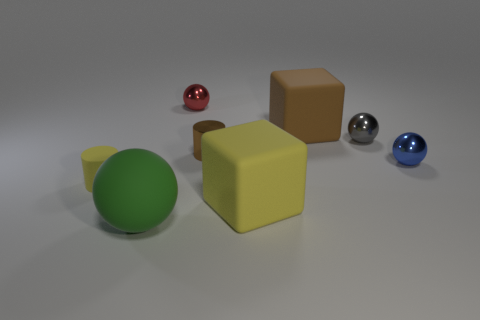How many tiny blue things are the same shape as the green object?
Your answer should be compact. 1. There is a yellow cylinder that is made of the same material as the large brown cube; what is its size?
Your answer should be compact. Small. How many cyan metallic cubes are the same size as the blue shiny thing?
Offer a terse response. 0. The small cylinder to the left of the small cylinder to the right of the big green sphere is what color?
Your answer should be compact. Yellow. Are there any other metal cylinders of the same color as the metallic cylinder?
Offer a very short reply. No. There is a metallic cylinder that is the same size as the blue object; what is its color?
Make the answer very short. Brown. Is the material of the small cylinder left of the large green rubber sphere the same as the small blue ball?
Give a very brief answer. No. Are there any gray things in front of the small metal ball behind the large block that is behind the tiny blue sphere?
Give a very brief answer. Yes. There is a yellow thing in front of the tiny matte cylinder; is its shape the same as the blue metallic object?
Your answer should be very brief. No. There is a big matte thing that is behind the yellow rubber object that is right of the small yellow object; what shape is it?
Keep it short and to the point. Cube. 